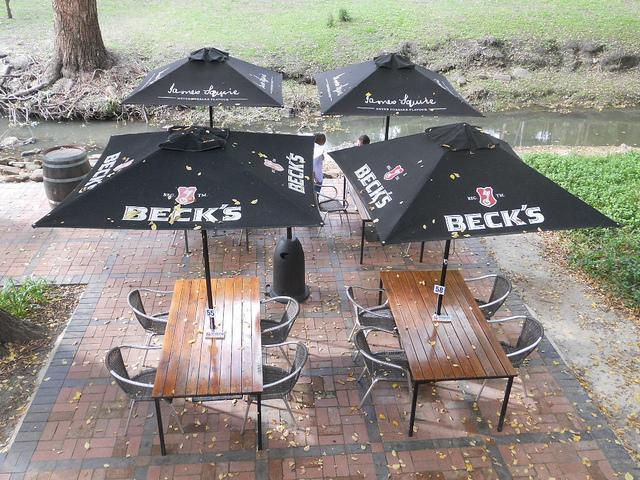What do the umbrellas offer those who sit here?
From the following four choices, select the correct answer to address the question.
Options: Shade, warmth, heat, radiation protection. Shade. What is this patio located next to?
Choose the correct response and explain in the format: 'Answer: answer
Rationale: rationale.'
Options: Fountain, beach, stream, pool. Answer: stream.
Rationale: This might also be called a creek in some areas of the world. 